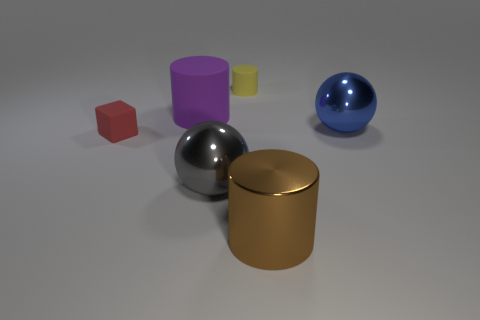Add 3 shiny cylinders. How many objects exist? 9 Subtract all balls. How many objects are left? 4 Add 5 purple rubber cylinders. How many purple rubber cylinders are left? 6 Add 4 large cylinders. How many large cylinders exist? 6 Subtract 0 purple balls. How many objects are left? 6 Subtract all red things. Subtract all purple rubber things. How many objects are left? 4 